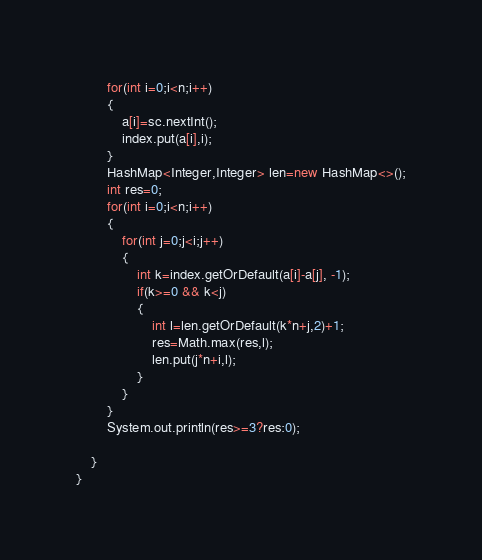<code> <loc_0><loc_0><loc_500><loc_500><_Java_>        for(int i=0;i<n;i++)
        {
            a[i]=sc.nextInt();
            index.put(a[i],i);
        }
        HashMap<Integer,Integer> len=new HashMap<>();
        int res=0;
        for(int i=0;i<n;i++)
        {
            for(int j=0;j<i;j++)
            {
                int k=index.getOrDefault(a[i]-a[j], -1);
                if(k>=0 && k<j)
                {
                    int l=len.getOrDefault(k*n+j,2)+1;
                    res=Math.max(res,l);
                    len.put(j*n+i,l);
                }
            }
        }
        System.out.println(res>=3?res:0);

    }
}</code> 